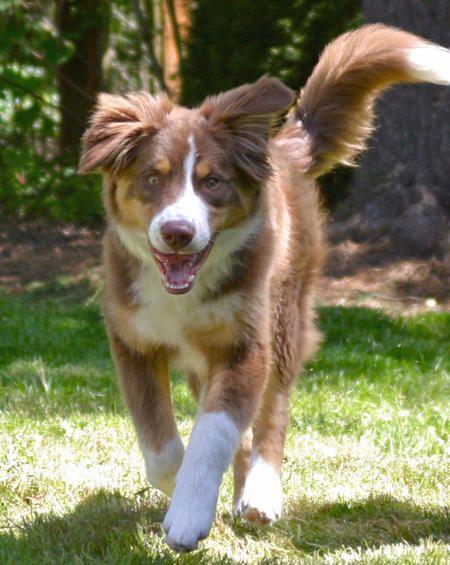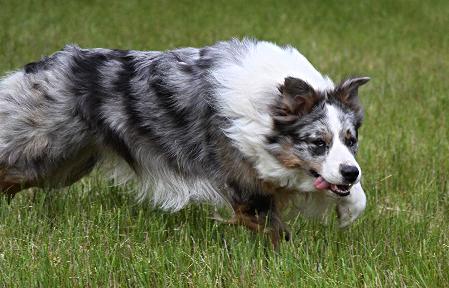The first image is the image on the left, the second image is the image on the right. Analyze the images presented: Is the assertion "There is no more than two dogs." valid? Answer yes or no. Yes. 